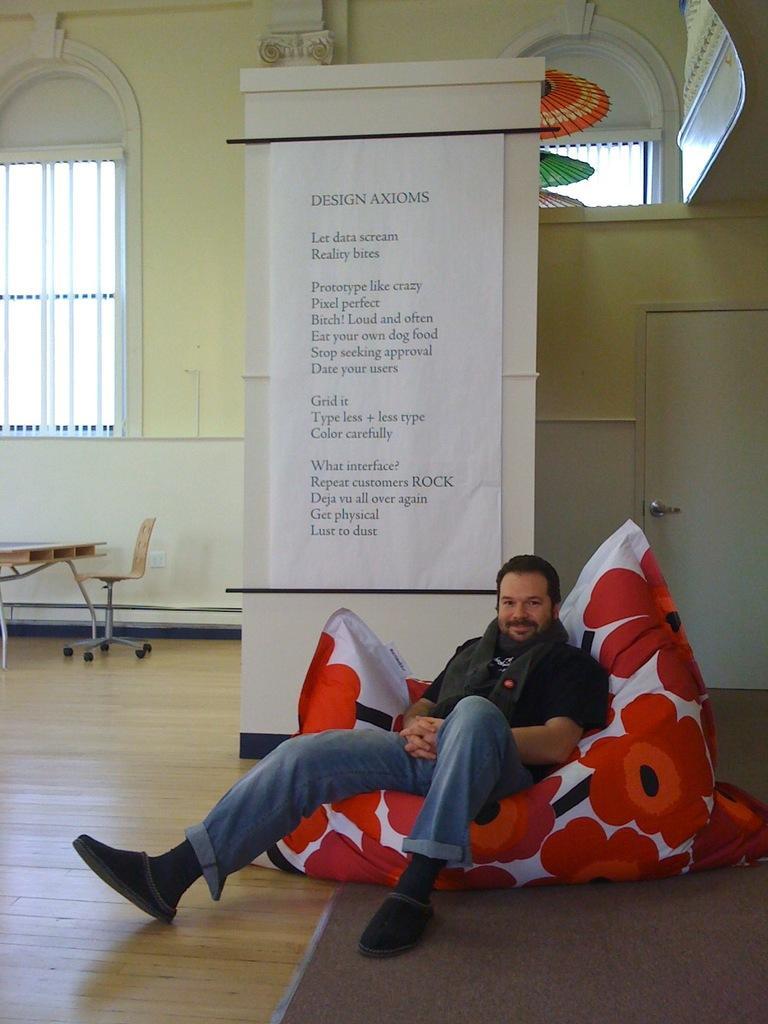Can you describe this image briefly? In this picture we can see man sitting on some cushion with beautiful flowers on it and in the background we can see some notice to the pillar and we have window, table, chair, floor, door. 